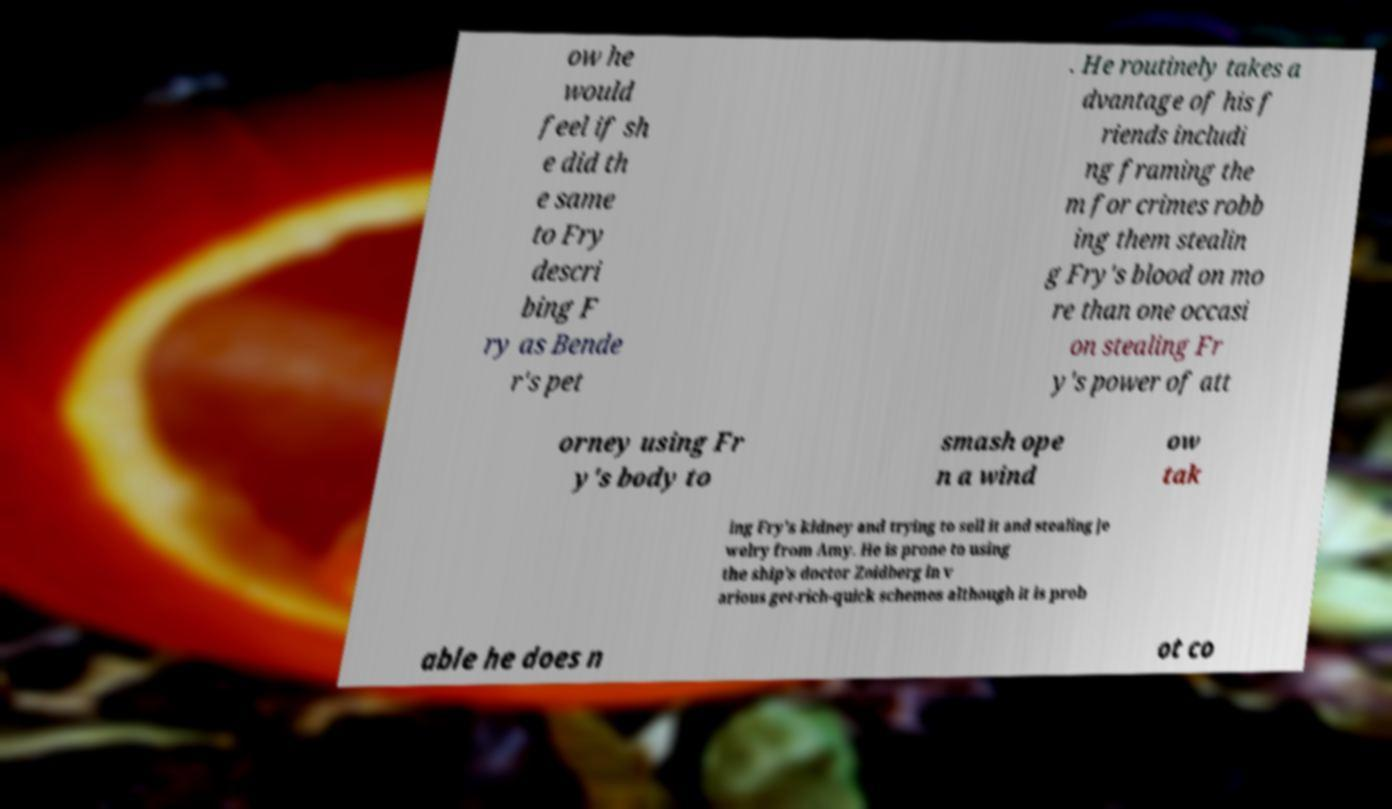Please identify and transcribe the text found in this image. ow he would feel if sh e did th e same to Fry descri bing F ry as Bende r's pet . He routinely takes a dvantage of his f riends includi ng framing the m for crimes robb ing them stealin g Fry's blood on mo re than one occasi on stealing Fr y's power of att orney using Fr y's body to smash ope n a wind ow tak ing Fry's kidney and trying to sell it and stealing je welry from Amy. He is prone to using the ship’s doctor Zoidberg in v arious get-rich-quick schemes although it is prob able he does n ot co 